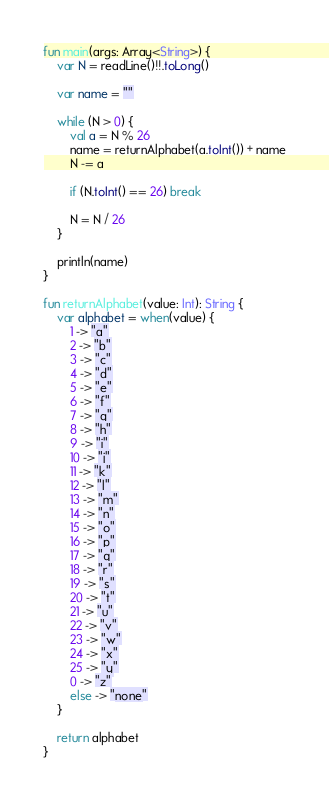<code> <loc_0><loc_0><loc_500><loc_500><_Kotlin_>fun main(args: Array<String>) {
  	var N = readLine()!!.toLong()
    
    var name = ""
    
    while (N > 0) {
        val a = N % 26
        name = returnAlphabet(a.toInt()) + name
        N -= a
        
        if (N.toInt() == 26) break
        
        N = N / 26
    }
    
    println(name)
}

fun returnAlphabet(value: Int): String {
    var alphabet = when(value) {
        1 -> "a"
        2 -> "b"
        3 -> "c"
        4 -> "d"
        5 -> "e"
        6 -> "f"
        7 -> "g"
        8 -> "h"
        9 -> "i"
        10 -> "j"
        11 -> "k"
        12 -> "l"
        13 -> "m"
        14 -> "n"
        15 -> "o"
        16 -> "p"
        17 -> "q"
        18 -> "r"
        19 -> "s"
        20 -> "t"
        21 -> "u"
        22 -> "v"
        23 -> "w"
        24 -> "x"
        25 -> "y"
        0 -> "z"
        else -> "none"
    }
    
    return alphabet
}</code> 